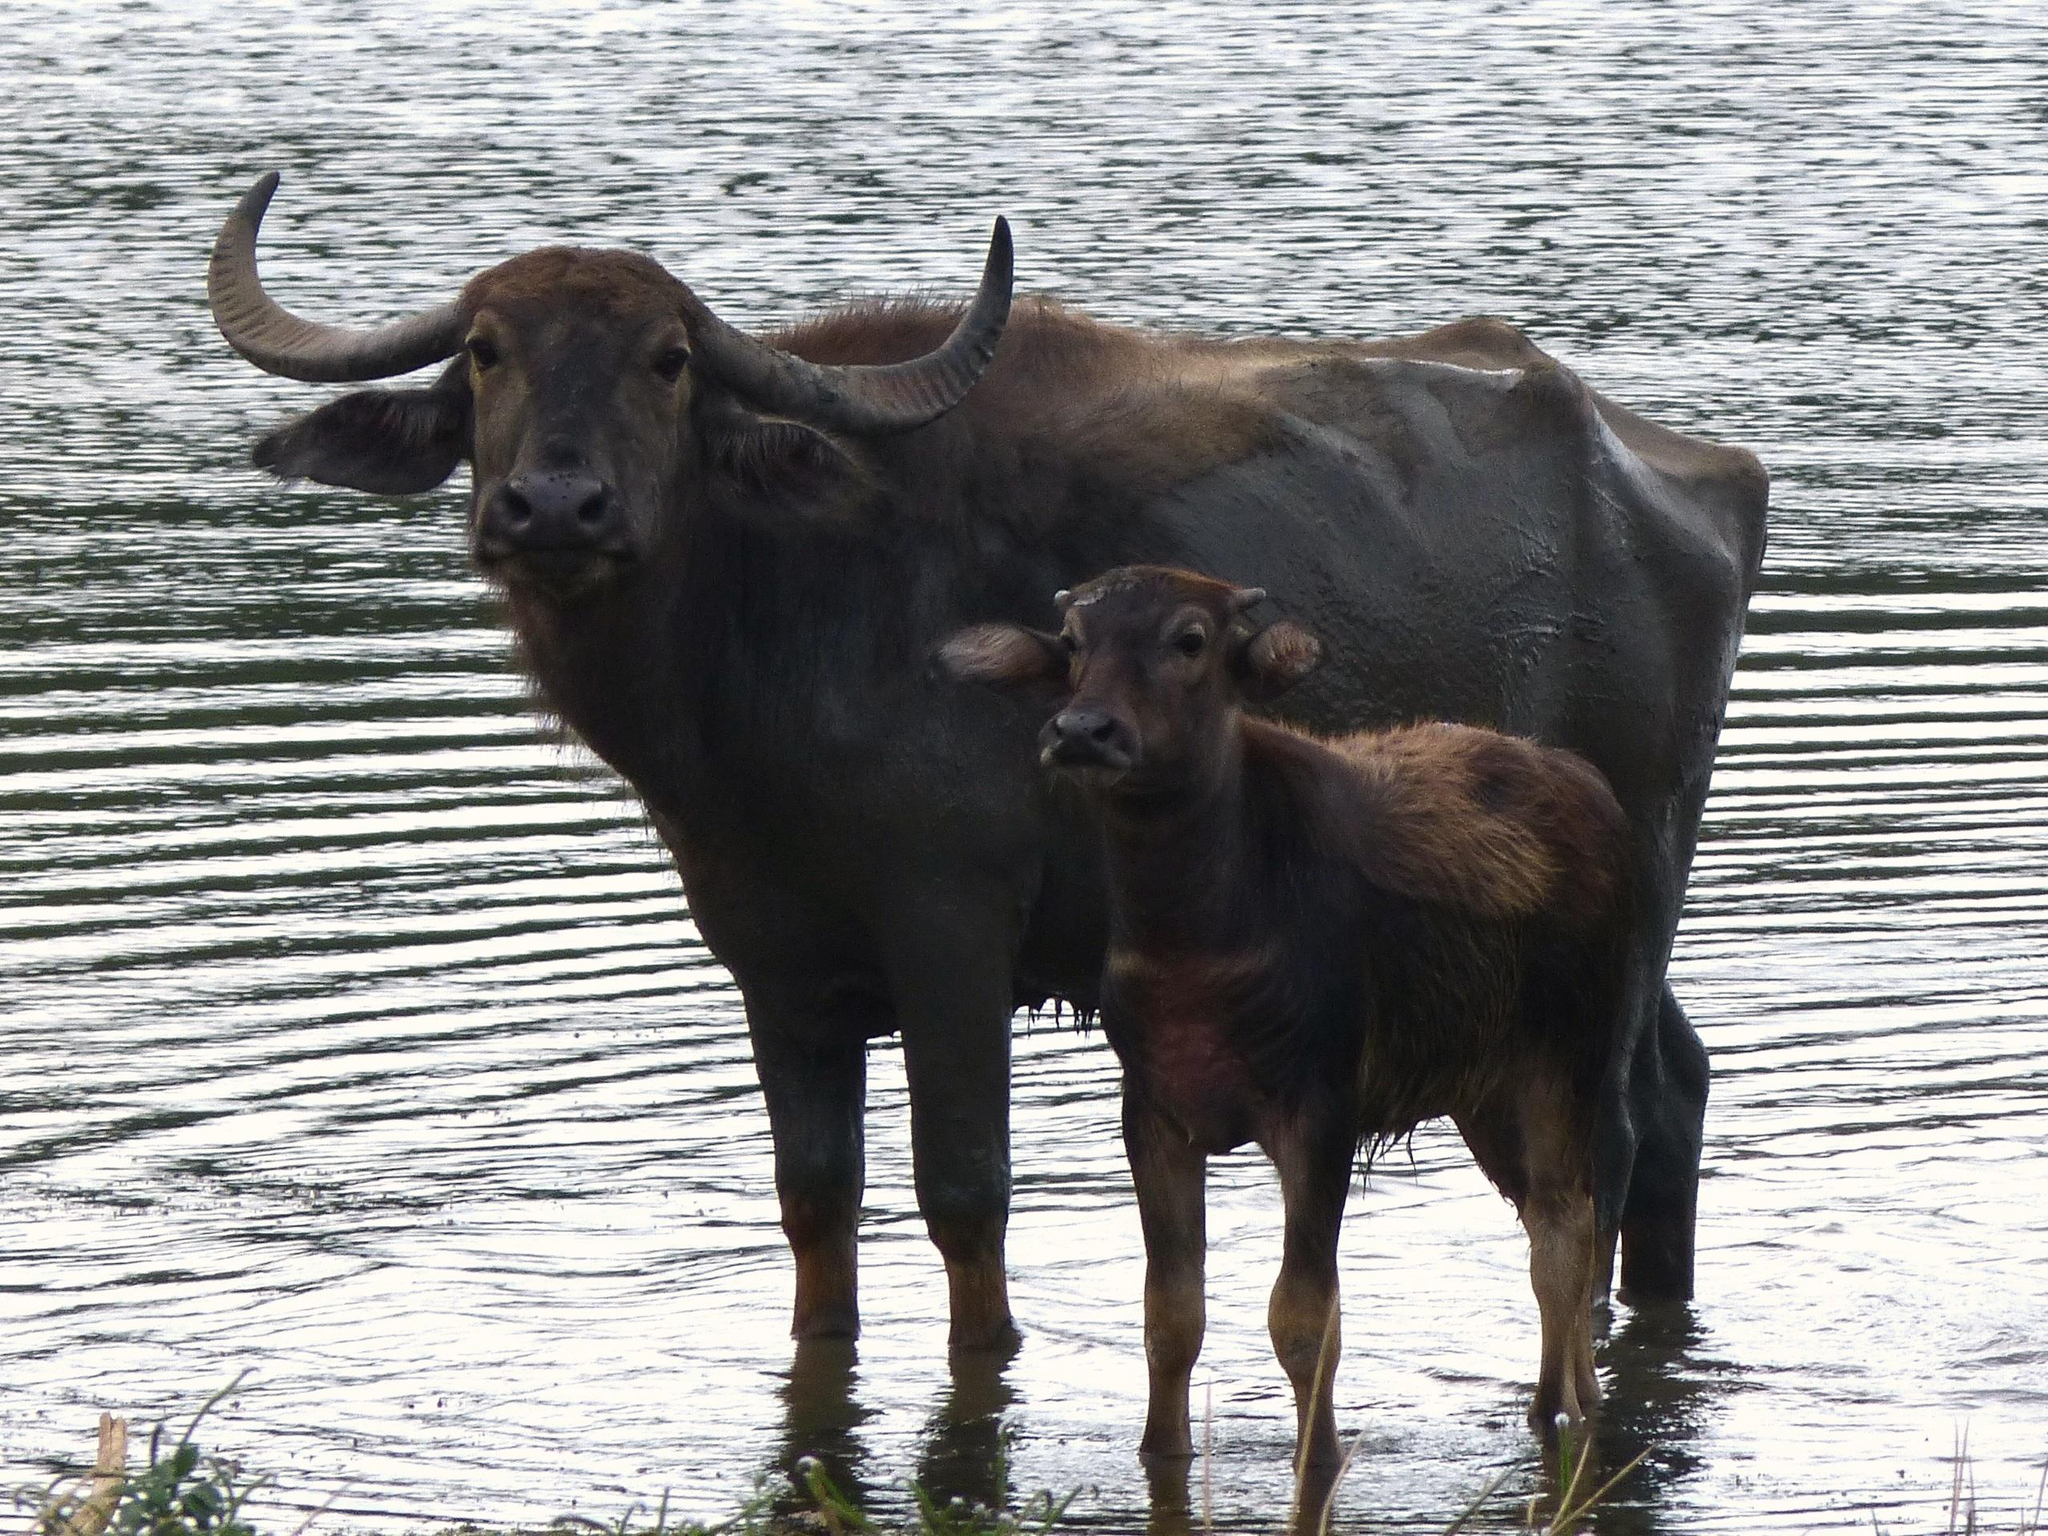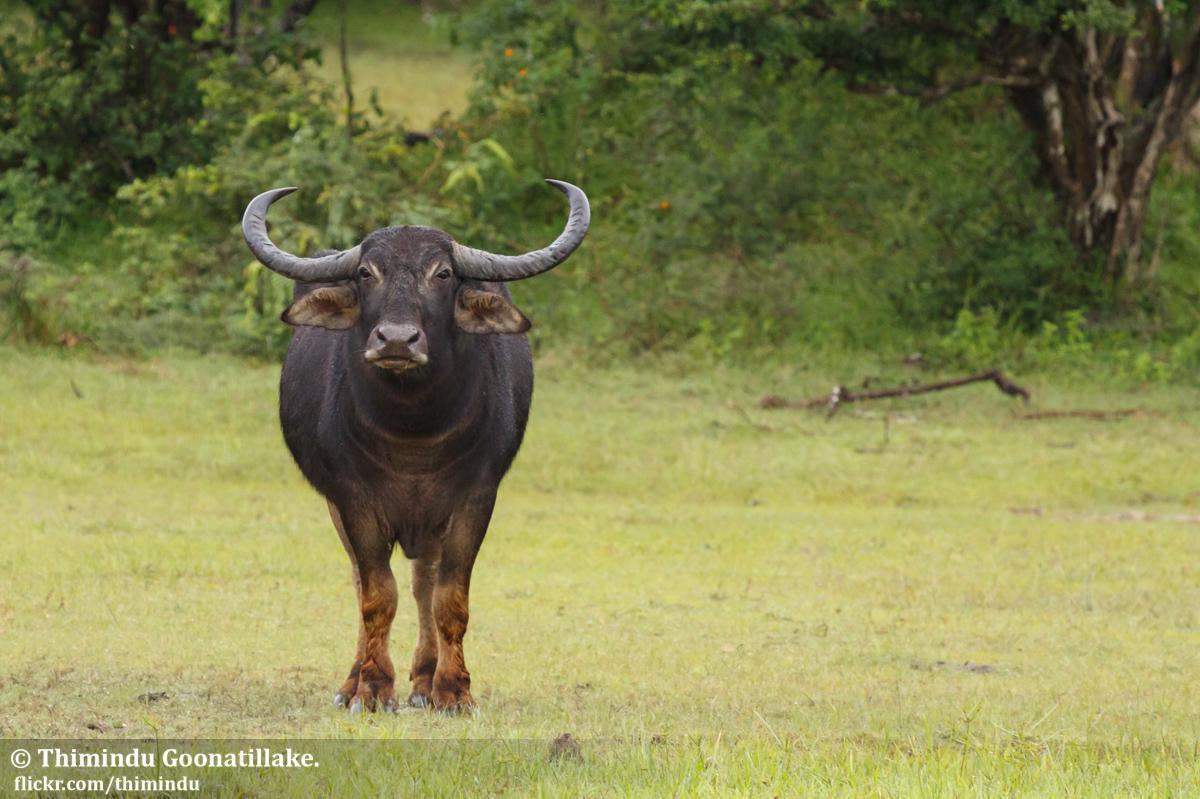The first image is the image on the left, the second image is the image on the right. Analyze the images presented: Is the assertion "The animals in the left photo are standing in water." valid? Answer yes or no. Yes. The first image is the image on the left, the second image is the image on the right. Analyze the images presented: Is the assertion "Left image shows water buffalo standing in wet area." valid? Answer yes or no. Yes. 